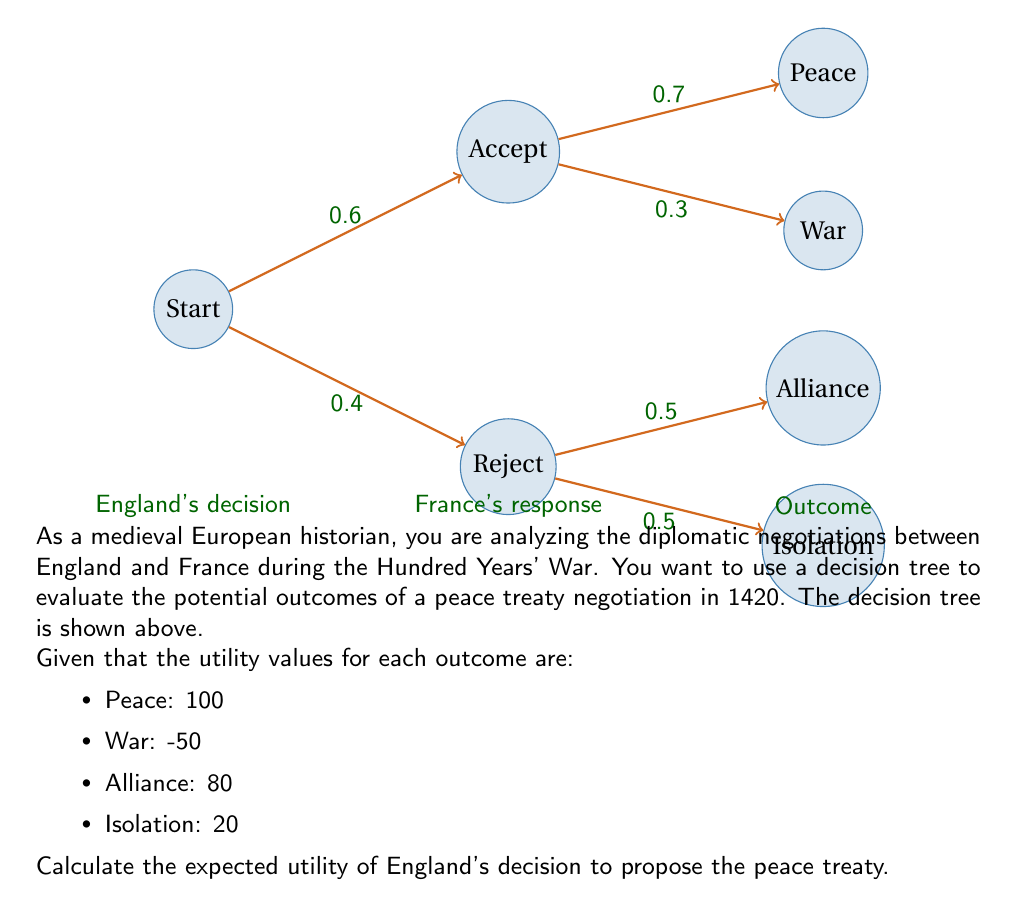Provide a solution to this math problem. To solve this problem, we need to use the decision tree and work backwards from the outcomes to determine the expected utility of England's decision to propose the peace treaty. We'll follow these steps:

1. Calculate the expected utility of France accepting the treaty:
   $$E(Accept) = 0.7 \times 100 + 0.3 \times (-50) = 70 - 15 = 55$$

2. Calculate the expected utility of France rejecting the treaty:
   $$E(Reject) = 0.5 \times 80 + 0.5 \times 20 = 40 + 10 = 50$$

3. Calculate the overall expected utility of proposing the treaty:
   $$E(Propose) = 0.6 \times E(Accept) + 0.4 \times E(Reject)$$
   $$E(Propose) = 0.6 \times 55 + 0.4 \times 50$$
   $$E(Propose) = 33 + 20 = 53$$

Therefore, the expected utility of England's decision to propose the peace treaty is 53.
Answer: 53 